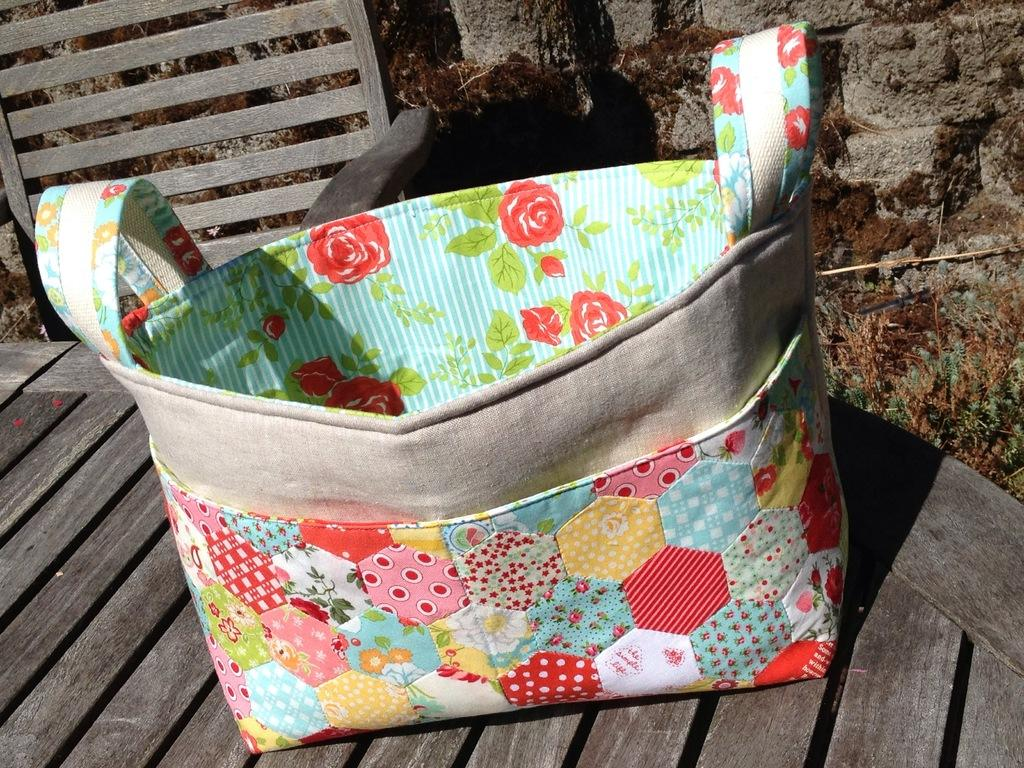What type of chair is in the image? There is a wooden chair in the image. What is on the chair? There is a bag on the chair. Can you describe the design of the bag? The bag has a floral design. How many handles does the bag have? The bag has two handles. What is the color pattern of the bag? The bag is multi-colored. What type of drink is being served in the image? There is no drink being served in the image; it only features a wooden chair with a bag on it. How many people are present in the image? There is no information about people in the image; it only features a wooden chair with a bag on it. 